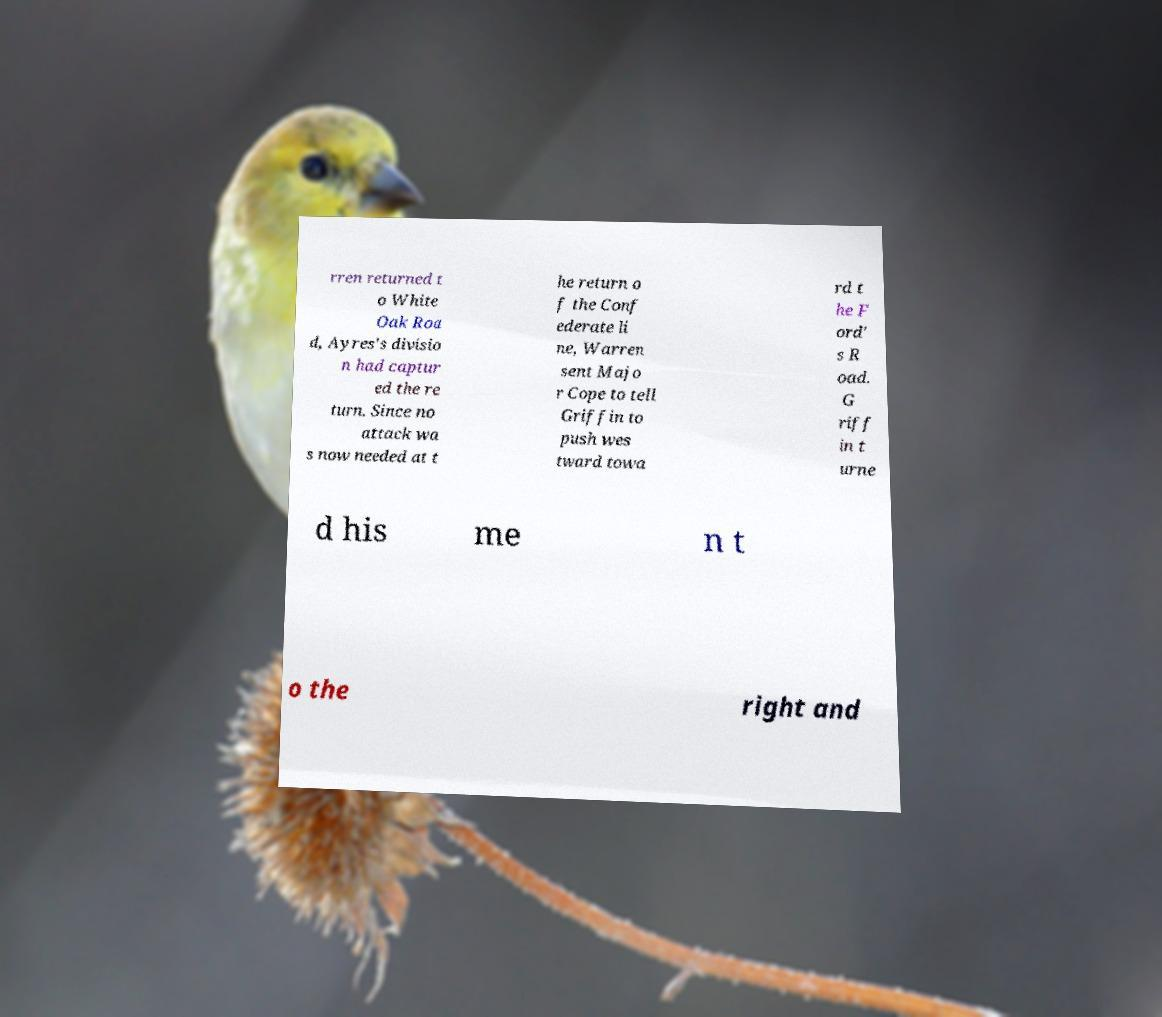Can you read and provide the text displayed in the image?This photo seems to have some interesting text. Can you extract and type it out for me? rren returned t o White Oak Roa d, Ayres's divisio n had captur ed the re turn. Since no attack wa s now needed at t he return o f the Conf ederate li ne, Warren sent Majo r Cope to tell Griffin to push wes tward towa rd t he F ord' s R oad. G riff in t urne d his me n t o the right and 